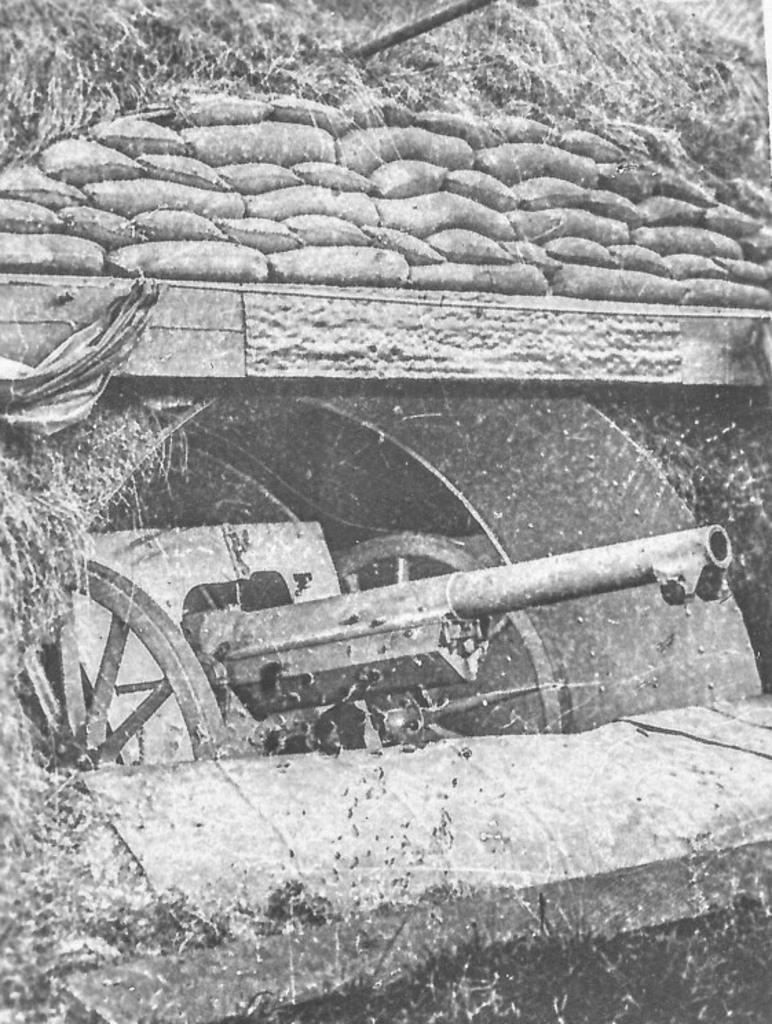How would you summarize this image in a sentence or two? It is the black and white image in which there is a panzer in the tunnel. Above the panzer there is a wall on which there are so many sacs. 